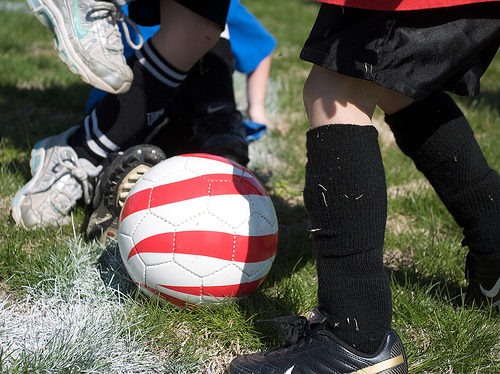<image>
Can you confirm if the ball is on the grass? Yes. Looking at the image, I can see the ball is positioned on top of the grass, with the grass providing support. Is there a white shoe in front of the ball? No. The white shoe is not in front of the ball. The spatial positioning shows a different relationship between these objects. 